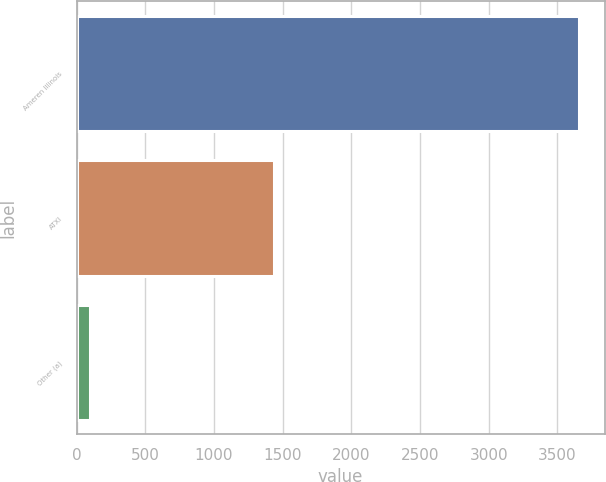<chart> <loc_0><loc_0><loc_500><loc_500><bar_chart><fcel>Ameren Illinois<fcel>ATXI<fcel>Other (a)<nl><fcel>3660<fcel>1440<fcel>100<nl></chart> 